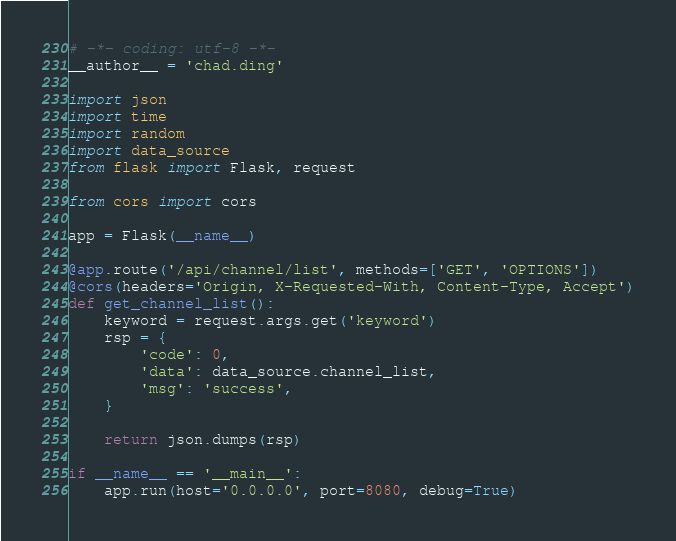<code> <loc_0><loc_0><loc_500><loc_500><_Python_># -*- coding: utf-8 -*-
__author__ = 'chad.ding'

import json
import time
import random
import data_source
from flask import Flask, request

from cors import cors

app = Flask(__name__)

@app.route('/api/channel/list', methods=['GET', 'OPTIONS'])
@cors(headers='Origin, X-Requested-With, Content-Type, Accept')
def get_channel_list():
    keyword = request.args.get('keyword')
    rsp = {
        'code': 0,
        'data': data_source.channel_list,
        'msg': 'success',
    }

    return json.dumps(rsp)

if __name__ == '__main__':
    app.run(host='0.0.0.0', port=8080, debug=True)</code> 